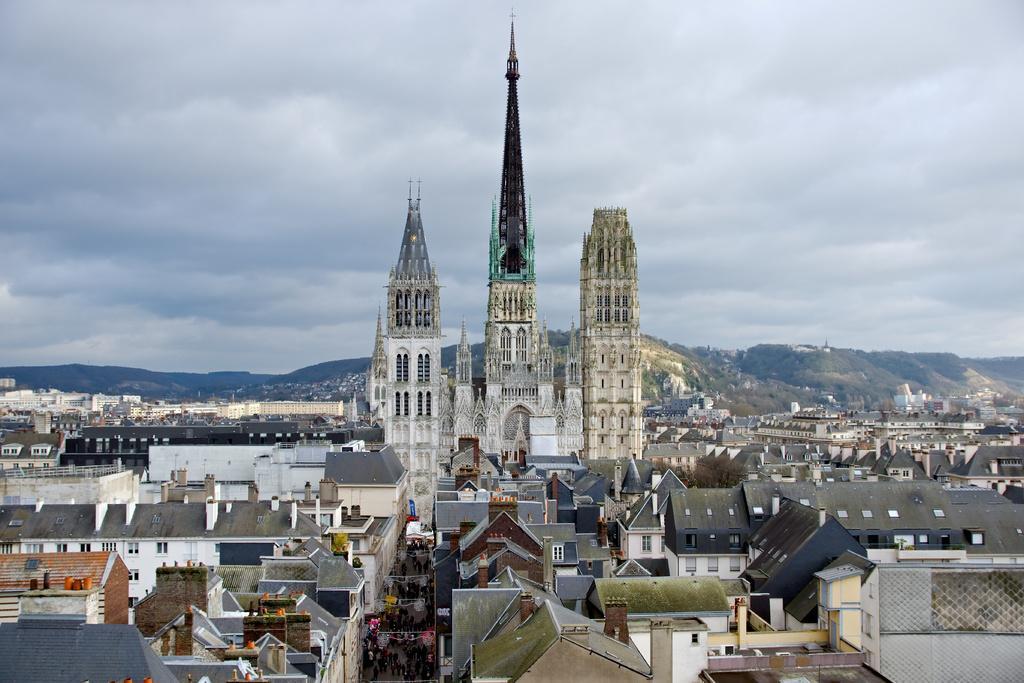Can you describe this image briefly? In this image I can see number of buildings, a street , few persons standing on the street and few orange colored objects. In the background I can see few buildings, few mountains and the sky. 